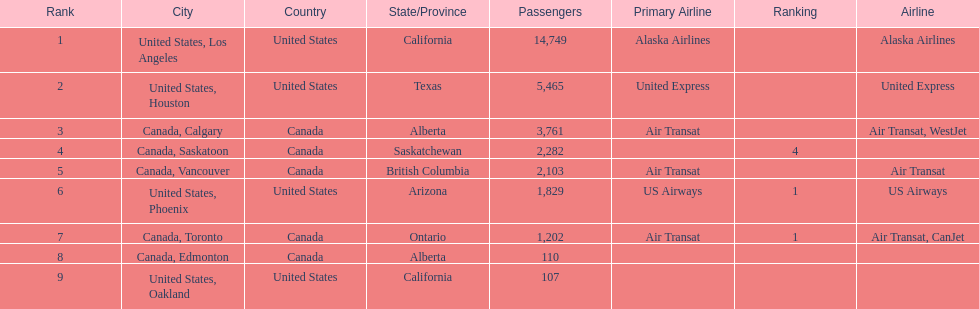The difference in passengers between los angeles and toronto 13,547. 